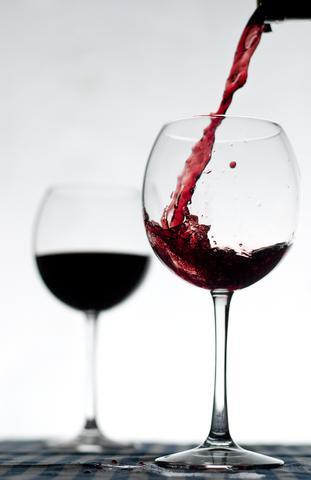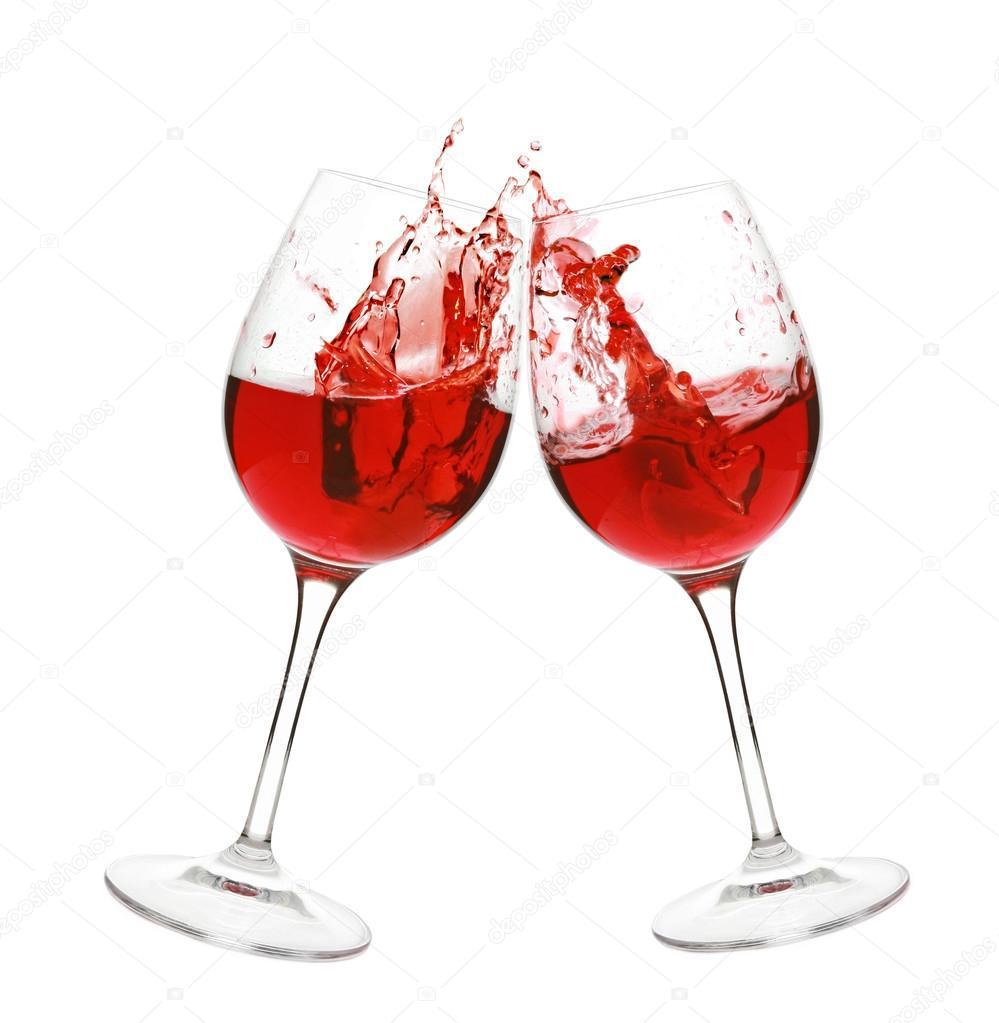The first image is the image on the left, the second image is the image on the right. For the images displayed, is the sentence "Two glasses are angled toward each other in one of the images." factually correct? Answer yes or no. Yes. The first image is the image on the left, the second image is the image on the right. Examine the images to the left and right. Is the description "There is one pair of overlapping glasses containing level liquids, and one pair of glasses that do not overlap." accurate? Answer yes or no. No. 